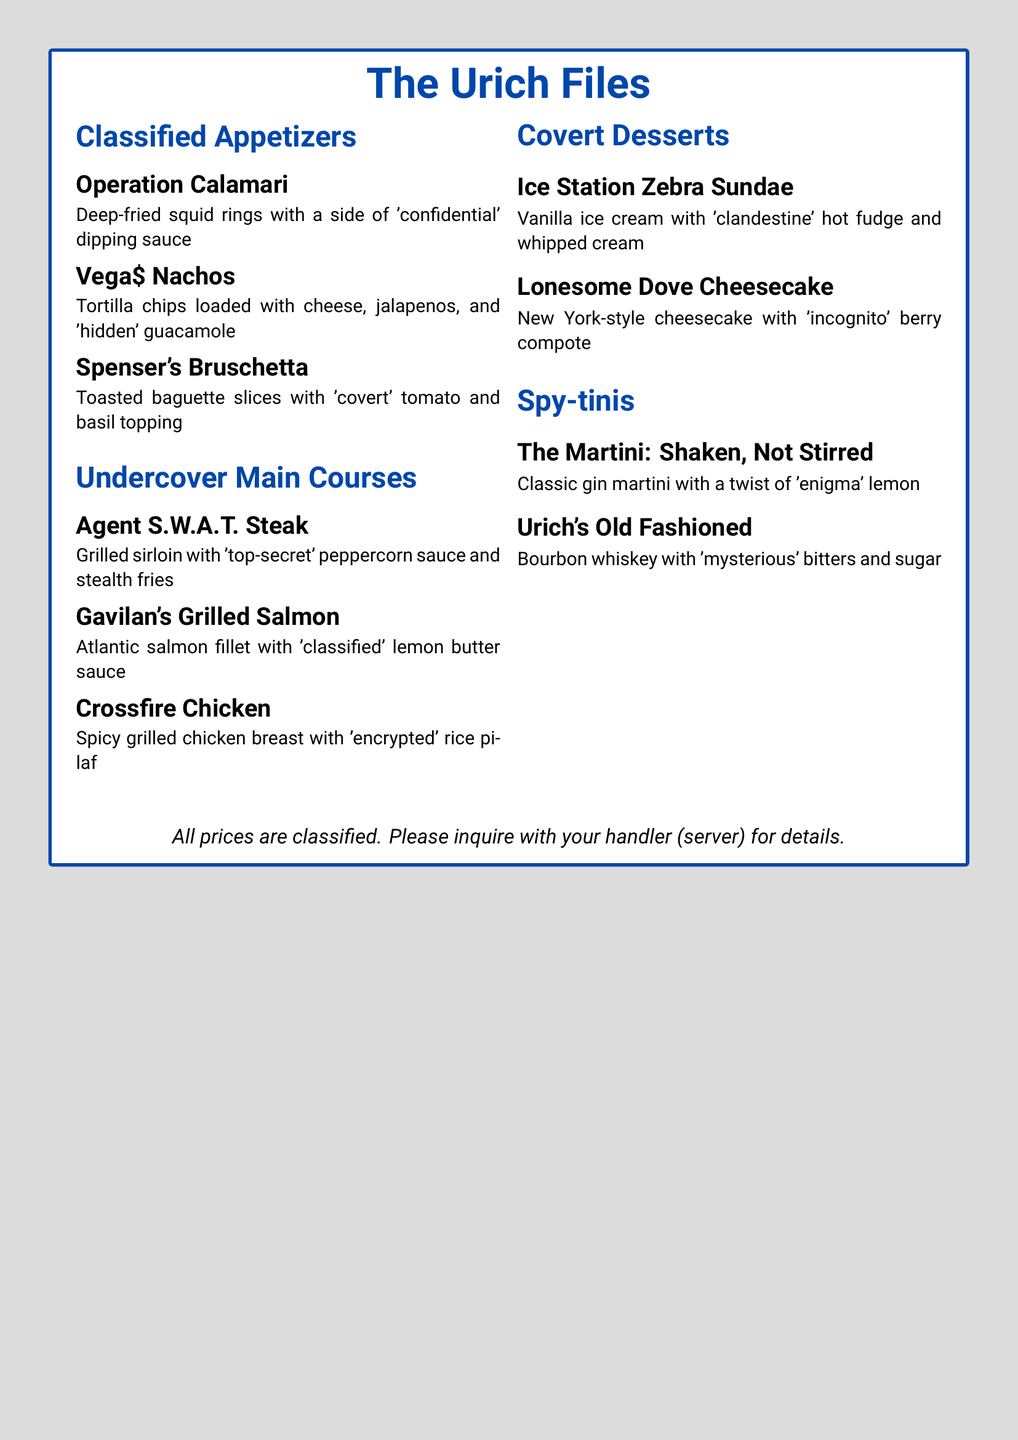What is the name of the restaurant? The restaurant is called "The Urich Files," as stated prominently at the top of the document.
Answer: The Urich Files What type of dish is "Operation Calamari"? "Operation Calamari" is classified under appetizers, specifically deep-fried squid rings.
Answer: Appetizer What is served with the "Agent S.W.A.T. Steak"? The dish is served with 'top-secret' peppercorn sauce and stealth fries, as listed in the main courses section.
Answer: 'Top-secret' peppercorn sauce and stealth fries How many Covert Desserts are listed? There are two desserts mentioned in the Covert Desserts section of the menu.
Answer: Two What is the coded name of the dessert that includes cheesecake? The dessert's coded name featuring cheesecake is "Lonesome Dove Cheesecake."
Answer: Lonesome Dove Cheesecake What beverage is associated with the phrase "Shaken, Not Stirred"? This phrase refers to "The Martini: Shaken, Not Stirred," found in the Spy-tinis section.
Answer: The Martini: Shaken, Not Stirred What ingredient is mentioned in "Urich's Old Fashioned"? The drink "Urich's Old Fashioned" includes bourbon whiskey, alongside 'mysterious' bitters and sugar.
Answer: Bourbon whiskey What color is used as the background of the menu? The background color of the menu is described as spy gray in the document.
Answer: Spy gray What is the setting for the prices of the dishes? The prices are stated to be classified, indicating they are not publicly listed on the menu.
Answer: Classified 